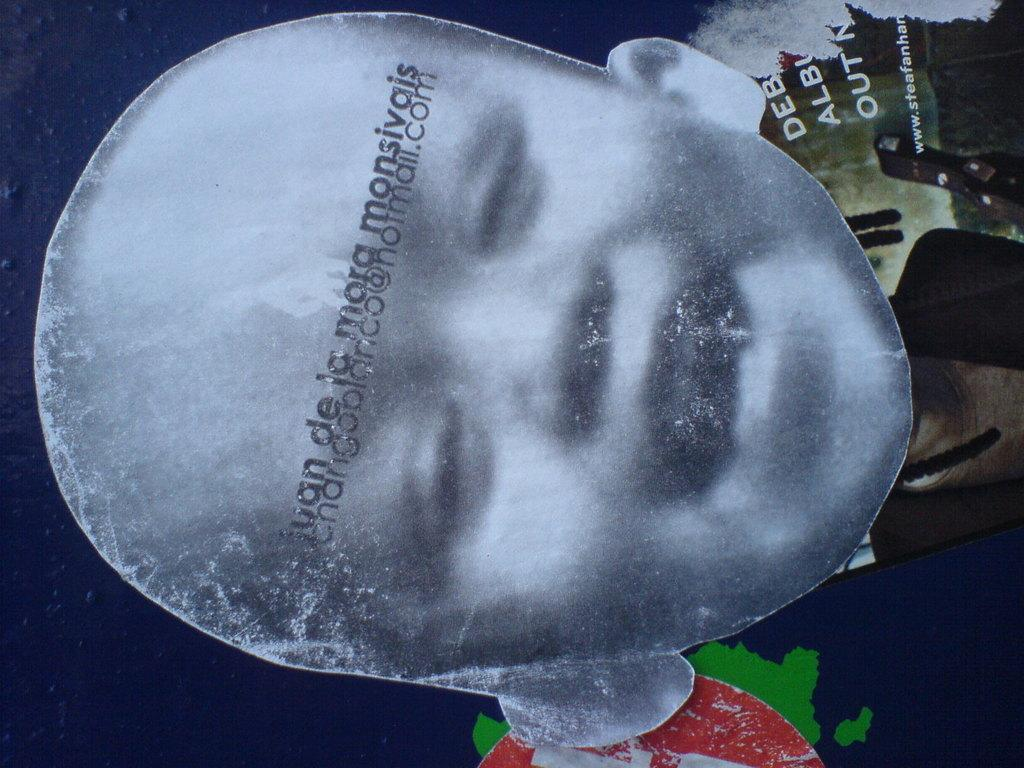What is the main subject of the image? The main subject of the image is a photo of a baby. How is the baby depicted in the photo? The baby is smiling in the photo. How many times has the baby folded the cracker in the image? There is no cracker present in the image, and therefore no folding can be observed. What type of property does the baby own in the image? There is no mention of property in the image, and the baby is a baby, so they do not own property. 